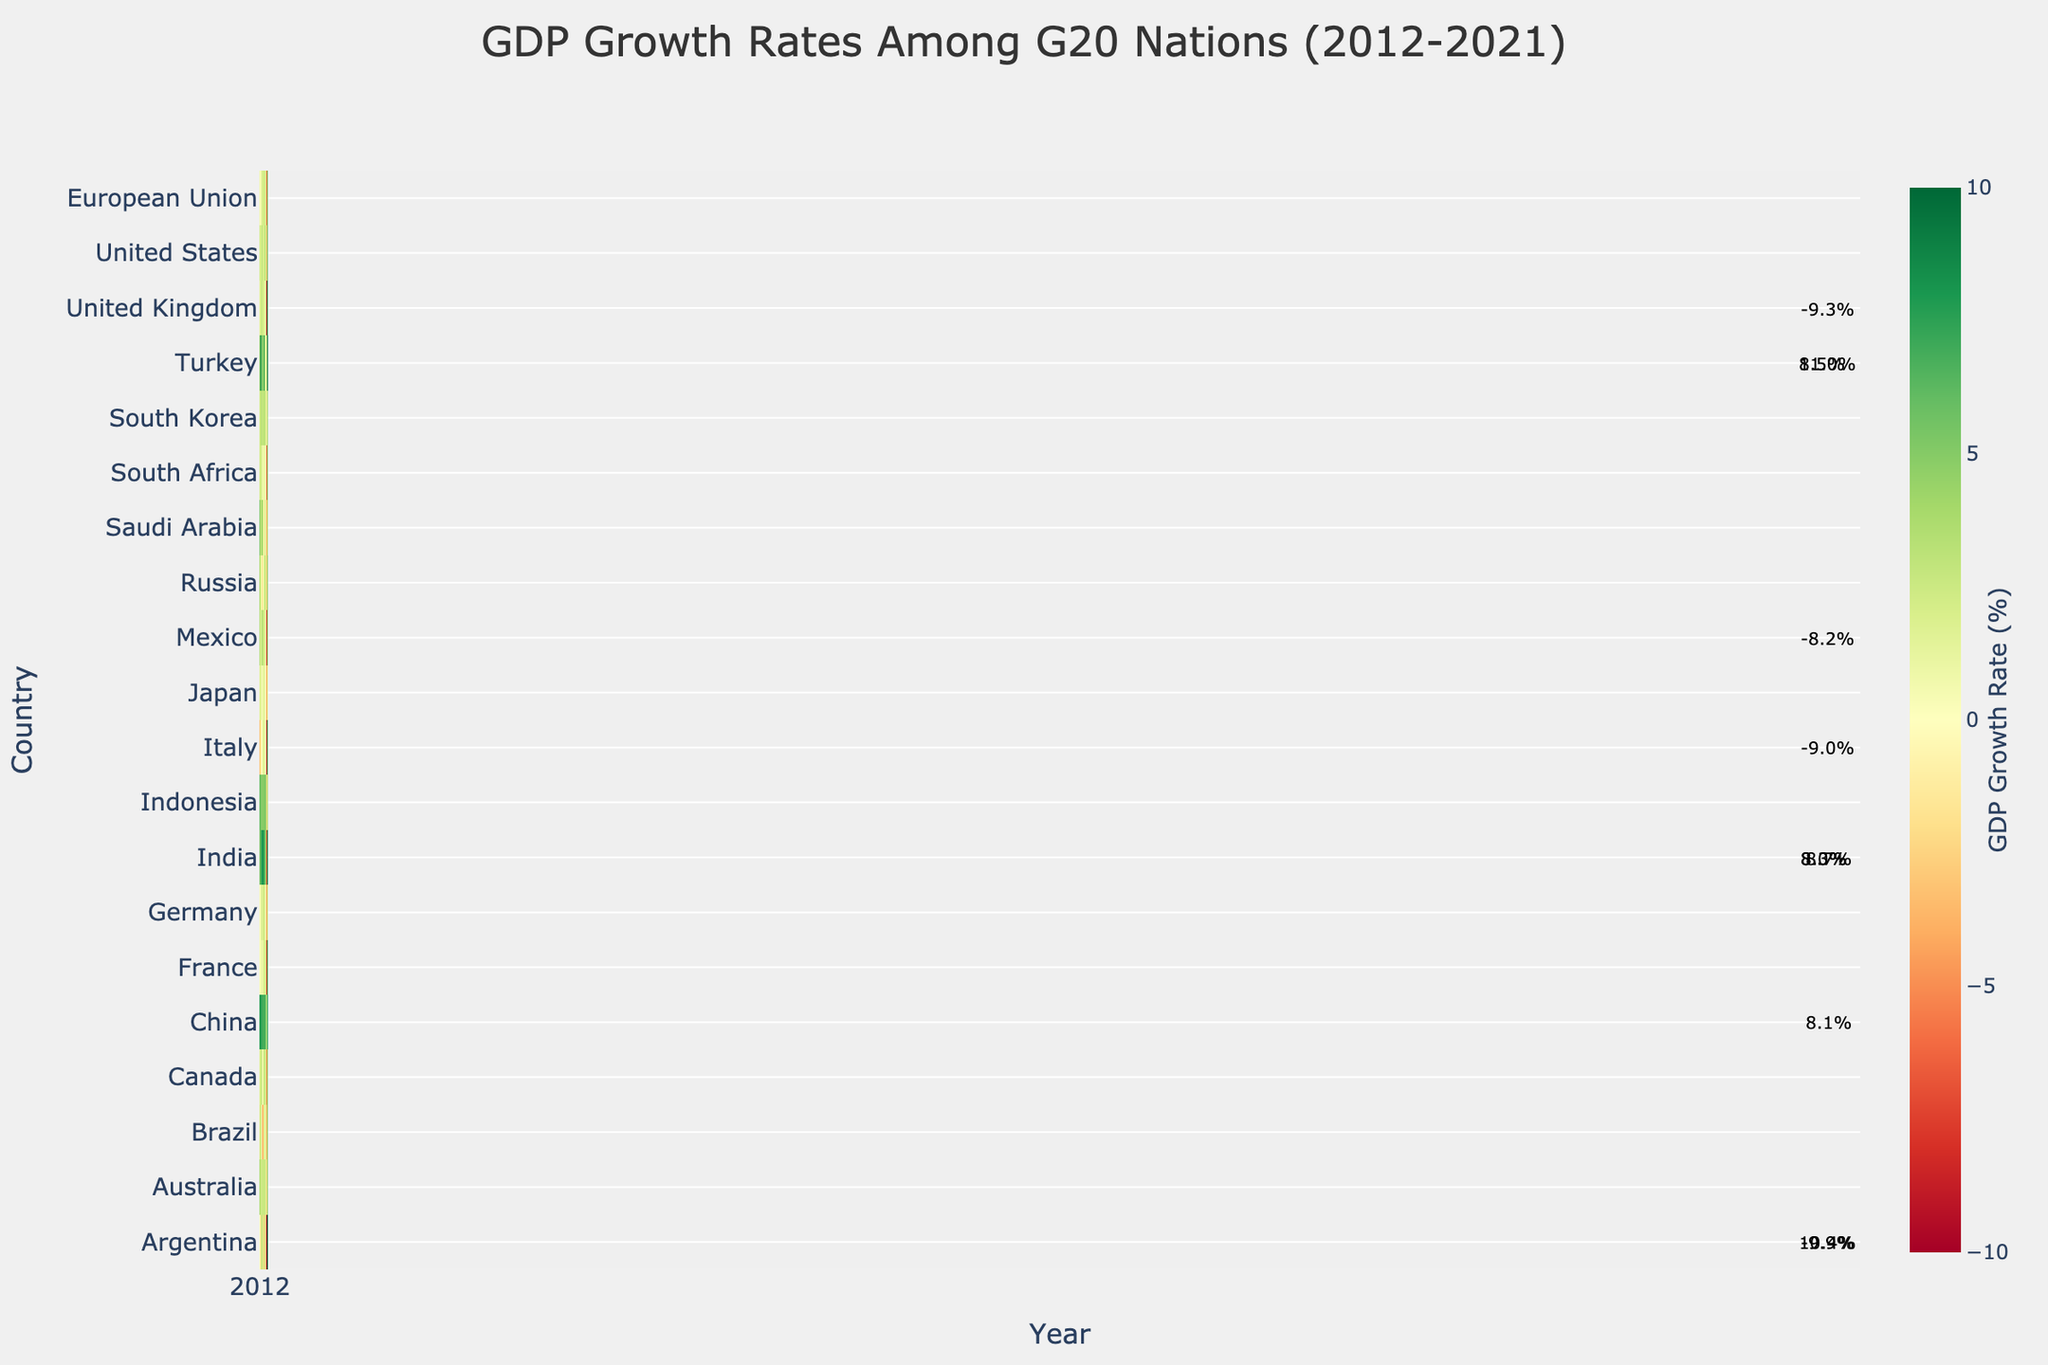Which G20 nation had the highest GDP growth rate in 2021? Look for the darkest green cell in the 2021 column of the heatmap. This would be Turkey with 11.0%.
Answer: Turkey Which countries experienced negative GDP growth rates in 2015? Identify the cells with a red color in the 2015 column, indicating negative growth. The countries are Brazil (-3.5%), Russia (-2.0%), and Argentina (2.7%).
Answer: Brazil, Russia, Argentina Which country saw the largest GDP growth rate change between 2020 and 2021? For each country, calculate the difference between the 2020 and 2021 values, then find the maximum difference. The largest change is for France, which went from -7.9% in 2020 to 6.8% in 2021, a change of 14.7%.
Answer: France Did any country have consistent positive GDP growth every year from 2012 to 2021? Scan through the heatmap to find a country with no red cells (negative values) for the entire period. Only China maintains positive growth throughout this period.
Answer: China How did the GDP growth rate of the United States change from 2019 to 2020 to 2021? Observe the colors for the United States in these years: 2019 (light green, 2.3%), 2020 (dark red, -3.4%), and 2021 (green, 5.7%). The growth rate fell significantly in 2020 then rebounded strongly in 2021.
Answer: Fell, then rebounded What was the average GDP growth rate for India over the decade? Sum all the annual growth rates for India from 2012 to 2021 and divide by the number of years (10). (5.5 + 6.4 + 7.4 + 8.0 + 8.3 + 6.8 + 6.5 + 4.0 - 7.3 + 8.7) / 10 = 5.43%.
Answer: 5.43% Which European countries had growth rates above 5% in 2021? Look for the cells in 2021 with values above 5%, which will be in green shades. The countries are France (6.8%) and Italy (6.6%), and European Union (5.3%).
Answer: France, Italy, European Union Compare the GDP growth rates of Germany and Japan in 2017. Which country had a higher rate? Locate the values for Germany and Japan in the 2017 column. Germany had a GDP growth rate of 2.6% while Japan had 2.2%. Therefore, Germany had a higher growth rate in 2017.
Answer: Germany Which year had the most G20 nations with negative GDP growth rates? Count the number of red cells in each year column and find the year with the highest count. 2020 has the most red cells, indicating the most nations with negative growth rates.
Answer: 2020 